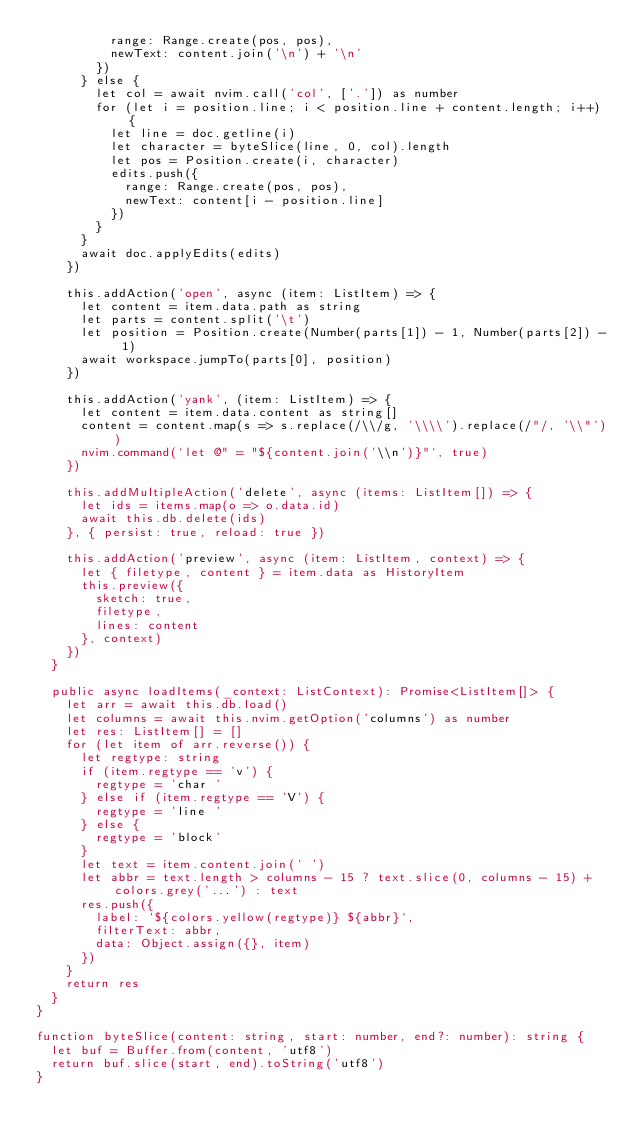<code> <loc_0><loc_0><loc_500><loc_500><_TypeScript_>          range: Range.create(pos, pos),
          newText: content.join('\n') + '\n'
        })
      } else {
        let col = await nvim.call('col', ['.']) as number
        for (let i = position.line; i < position.line + content.length; i++) {
          let line = doc.getline(i)
          let character = byteSlice(line, 0, col).length
          let pos = Position.create(i, character)
          edits.push({
            range: Range.create(pos, pos),
            newText: content[i - position.line]
          })
        }
      }
      await doc.applyEdits(edits)
    })

    this.addAction('open', async (item: ListItem) => {
      let content = item.data.path as string
      let parts = content.split('\t')
      let position = Position.create(Number(parts[1]) - 1, Number(parts[2]) - 1)
      await workspace.jumpTo(parts[0], position)
    })

    this.addAction('yank', (item: ListItem) => {
      let content = item.data.content as string[]
      content = content.map(s => s.replace(/\\/g, '\\\\').replace(/"/, '\\"'))
      nvim.command(`let @" = "${content.join('\\n')}"`, true)
    })

    this.addMultipleAction('delete', async (items: ListItem[]) => {
      let ids = items.map(o => o.data.id)
      await this.db.delete(ids)
    }, { persist: true, reload: true })

    this.addAction('preview', async (item: ListItem, context) => {
      let { filetype, content } = item.data as HistoryItem
      this.preview({
        sketch: true,
        filetype,
        lines: content
      }, context)
    })
  }

  public async loadItems(_context: ListContext): Promise<ListItem[]> {
    let arr = await this.db.load()
    let columns = await this.nvim.getOption('columns') as number
    let res: ListItem[] = []
    for (let item of arr.reverse()) {
      let regtype: string
      if (item.regtype == 'v') {
        regtype = 'char '
      } else if (item.regtype == 'V') {
        regtype = 'line '
      } else {
        regtype = 'block'
      }
      let text = item.content.join(' ')
      let abbr = text.length > columns - 15 ? text.slice(0, columns - 15) + colors.grey('...') : text
      res.push({
        label: `${colors.yellow(regtype)} ${abbr}`,
        filterText: abbr,
        data: Object.assign({}, item)
      })
    }
    return res
  }
}

function byteSlice(content: string, start: number, end?: number): string {
  let buf = Buffer.from(content, 'utf8')
  return buf.slice(start, end).toString('utf8')
}
</code> 